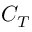<formula> <loc_0><loc_0><loc_500><loc_500>C _ { T }</formula> 